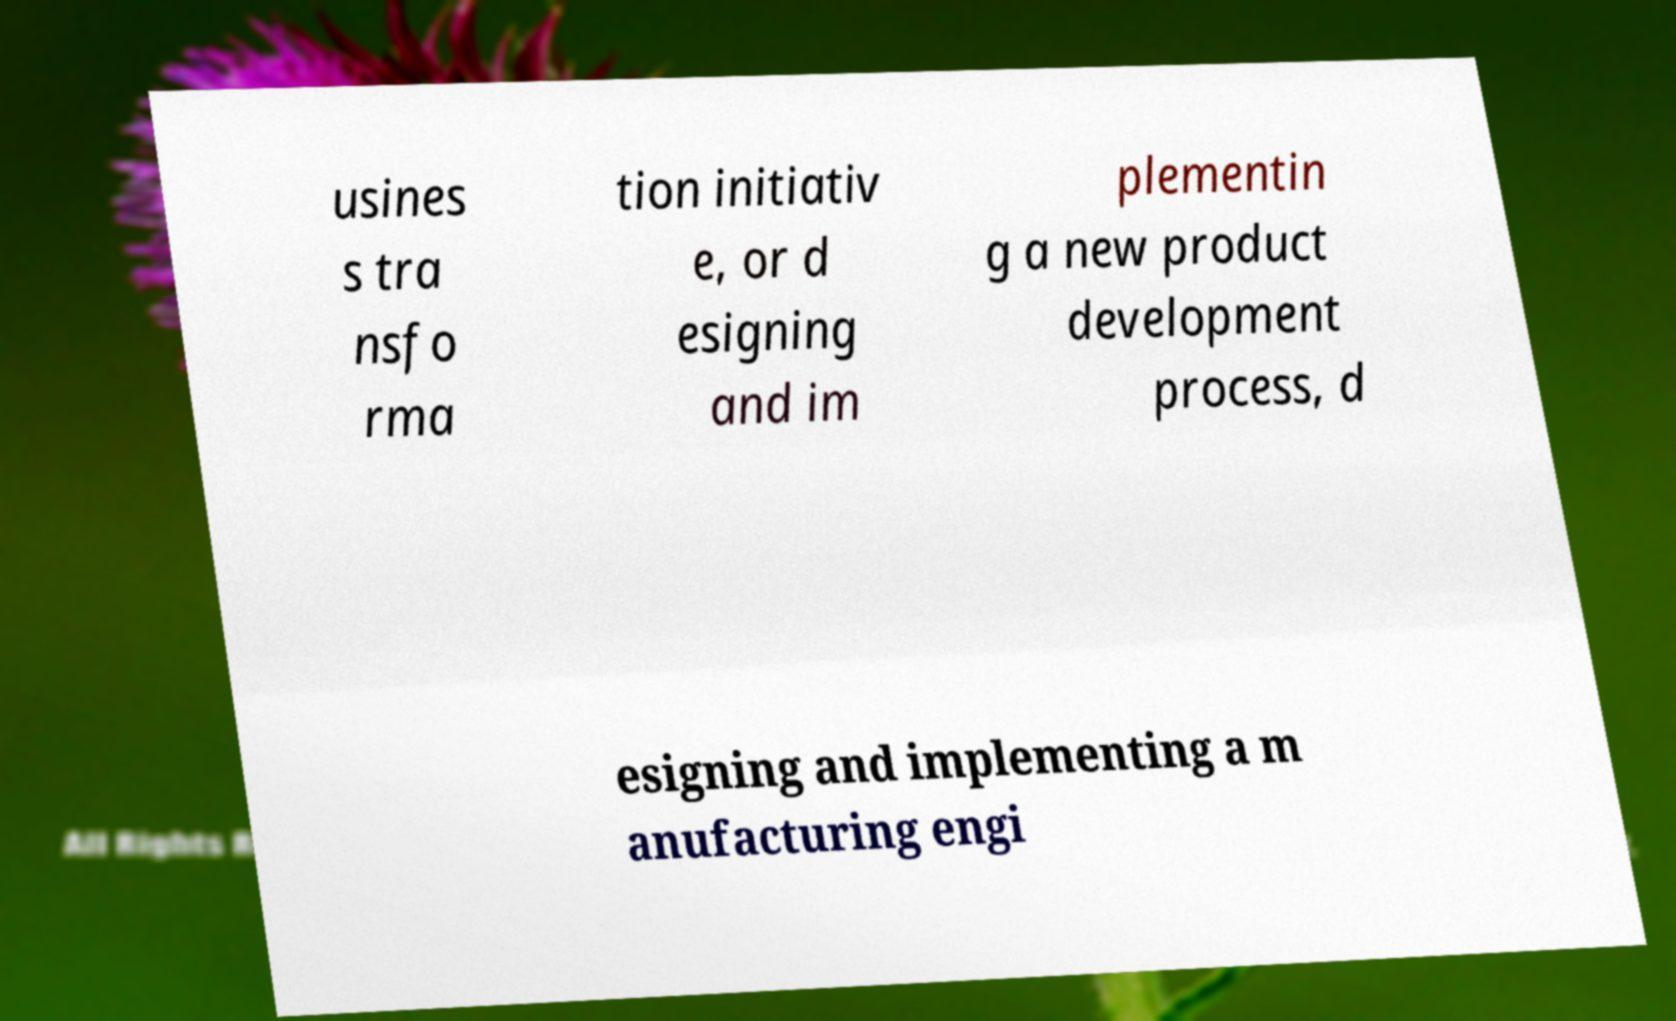Please identify and transcribe the text found in this image. usines s tra nsfo rma tion initiativ e, or d esigning and im plementin g a new product development process, d esigning and implementing a m anufacturing engi 